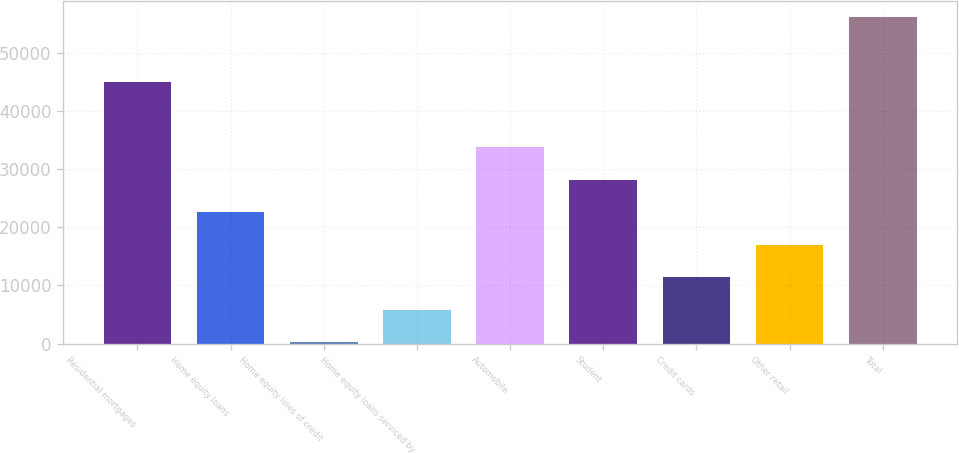Convert chart. <chart><loc_0><loc_0><loc_500><loc_500><bar_chart><fcel>Residential mortgages<fcel>Home equity loans<fcel>Home equity lines of credit<fcel>Home equity loans serviced by<fcel>Automobile<fcel>Student<fcel>Credit cards<fcel>Other retail<fcel>Total<nl><fcel>44858.2<fcel>22538.6<fcel>219<fcel>5798.9<fcel>33698.4<fcel>28118.5<fcel>11378.8<fcel>16958.7<fcel>56018<nl></chart> 